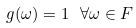<formula> <loc_0><loc_0><loc_500><loc_500>g ( \omega ) = 1 \ \forall \omega \in F</formula> 